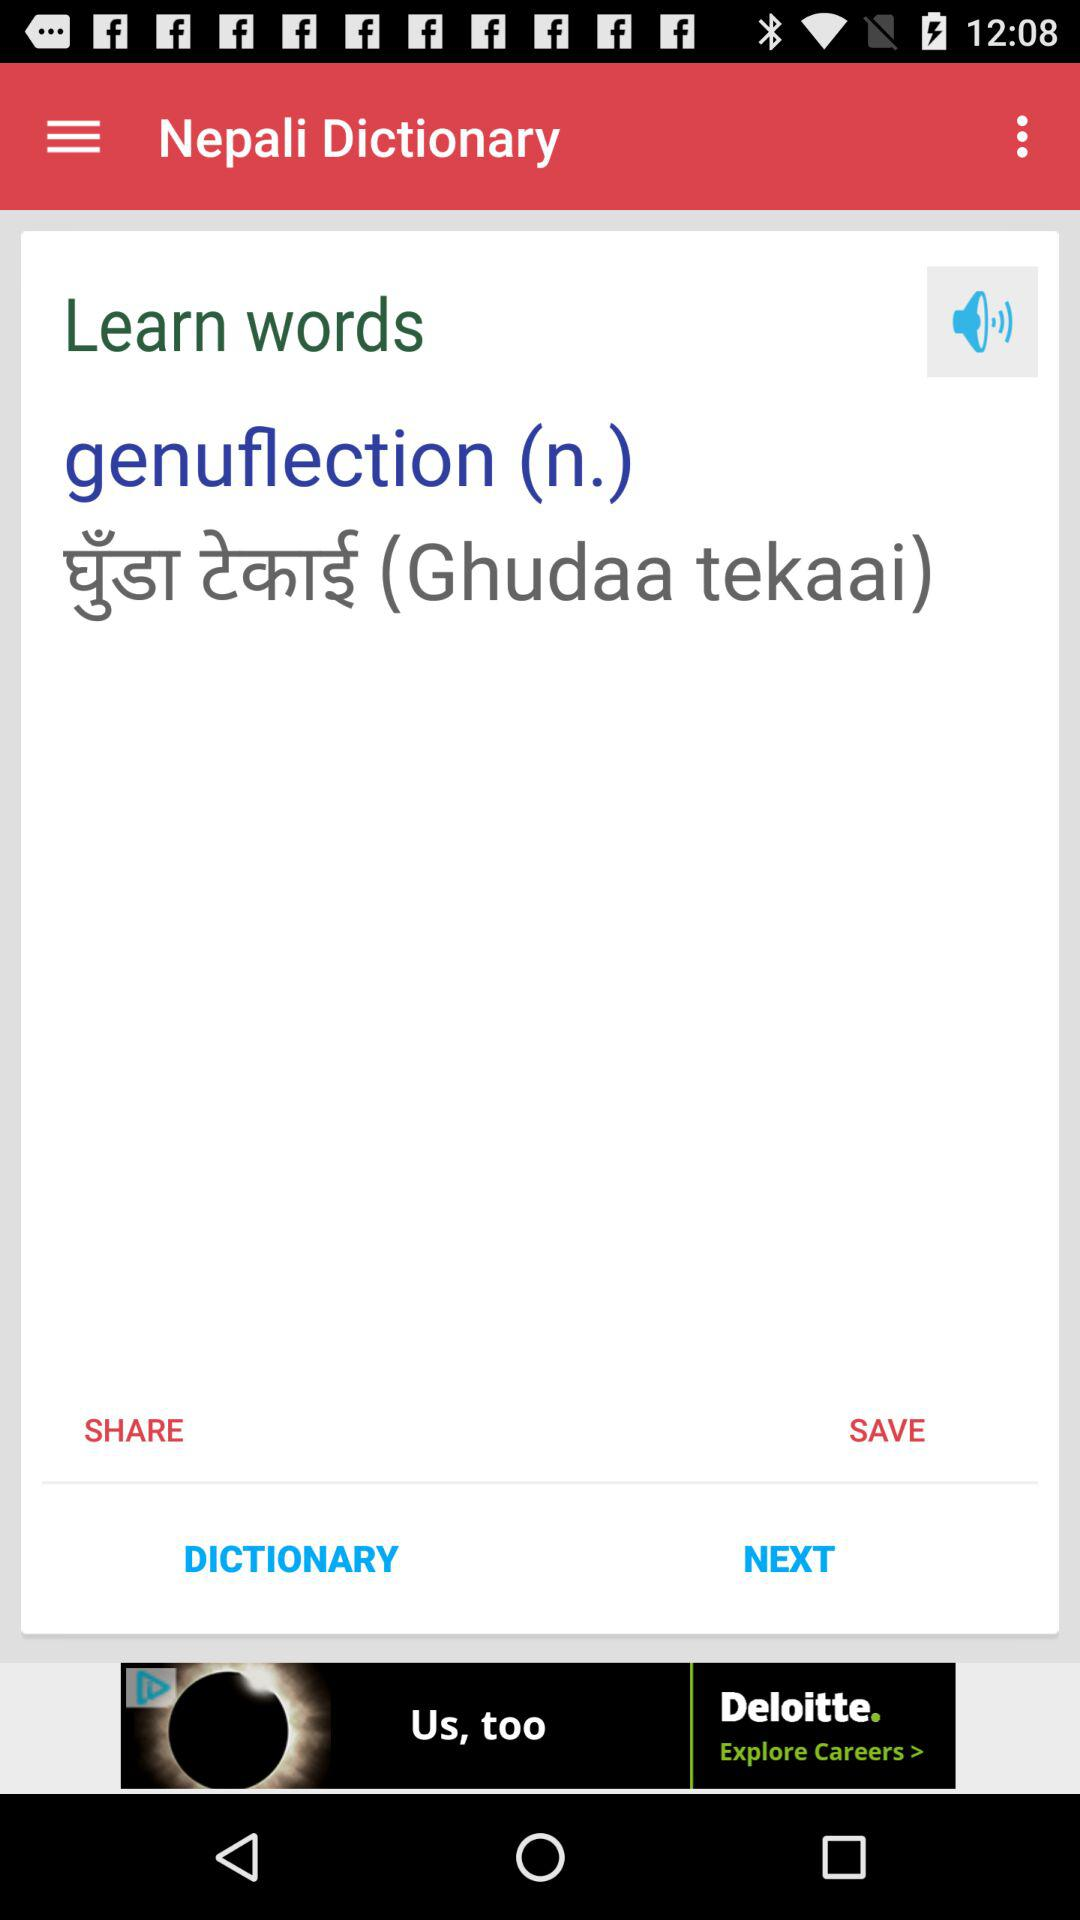What is the app name? The app name is "Nepali Dictionary". 